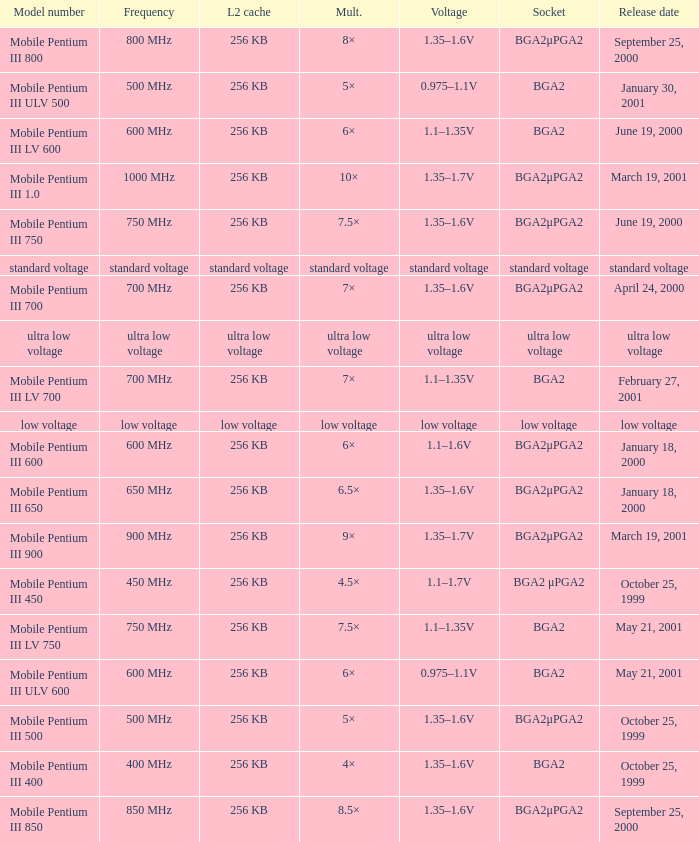Which model has a frequency of 750 mhz and a socket of bga2μpga2? Mobile Pentium III 750. 